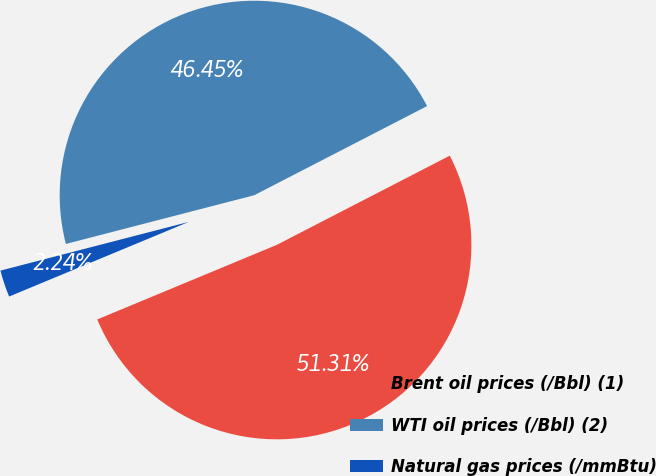<chart> <loc_0><loc_0><loc_500><loc_500><pie_chart><fcel>Brent oil prices (/Bbl) (1)<fcel>WTI oil prices (/Bbl) (2)<fcel>Natural gas prices (/mmBtu)<nl><fcel>51.31%<fcel>46.45%<fcel>2.24%<nl></chart> 